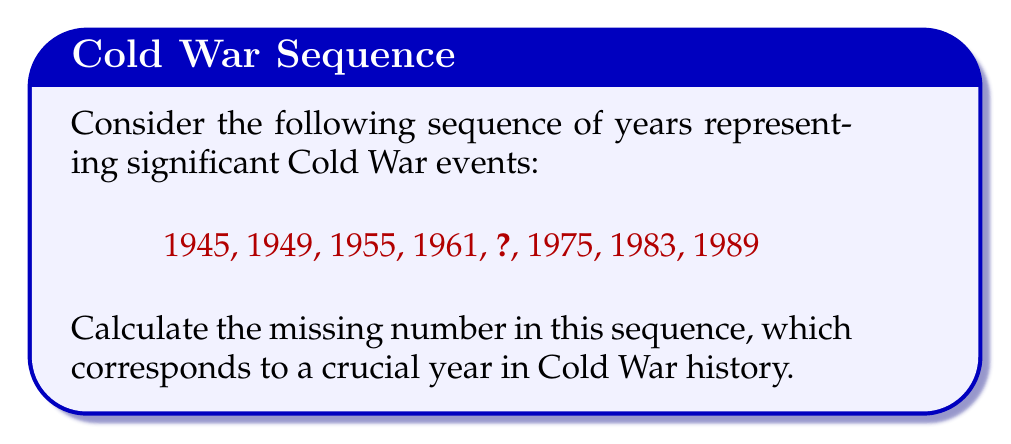Solve this math problem. To solve this problem, we need to identify the pattern in the sequence and determine the missing year. Let's analyze the differences between consecutive terms:

1. $1949 - 1945 = 4$
2. $1955 - 1949 = 6$
3. $1961 - 1955 = 6$
4. Missing term - 1961 = ?
5. $1975 - $ Missing term = ?
6. $1983 - 1975 = 8$
7. $1989 - 1983 = 6$

We can observe that the differences between consecutive terms are not constant, but they follow a pattern:

$4, 6, 6, ?, ?, 8, 6$

The pattern suggests that the difference increases by 2 every other term, with 6 repeating in between. Following this pattern, we can deduce that the two missing differences should be 6 and 8.

Therefore, the missing term can be calculated as:

$1961 + 6 = 1967$

To verify:
$1975 - 1967 = 8$, which fits the pattern.

The year 1967 is indeed significant in Cold War history, as it marks the Six-Day War in the Middle East, which had major implications for US-Soviet relations.
Answer: 1967 